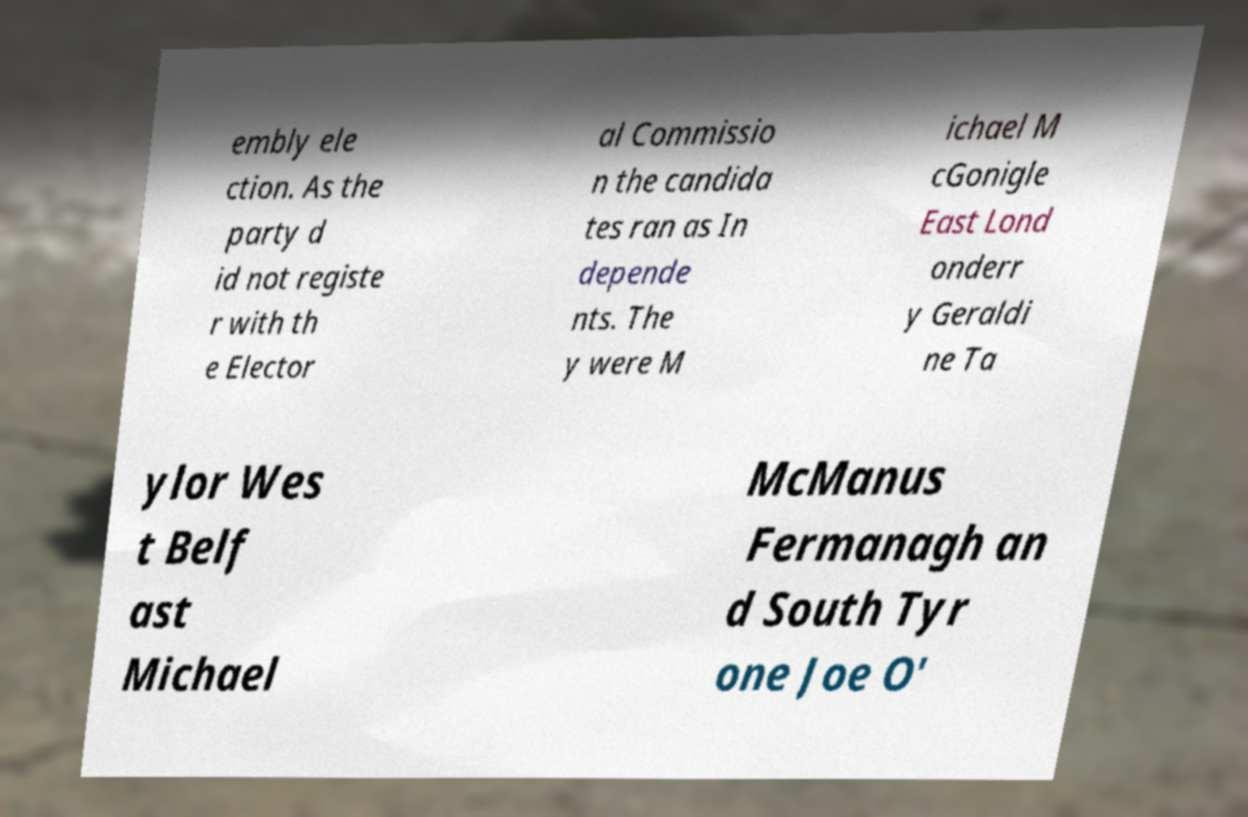For documentation purposes, I need the text within this image transcribed. Could you provide that? embly ele ction. As the party d id not registe r with th e Elector al Commissio n the candida tes ran as In depende nts. The y were M ichael M cGonigle East Lond onderr y Geraldi ne Ta ylor Wes t Belf ast Michael McManus Fermanagh an d South Tyr one Joe O' 